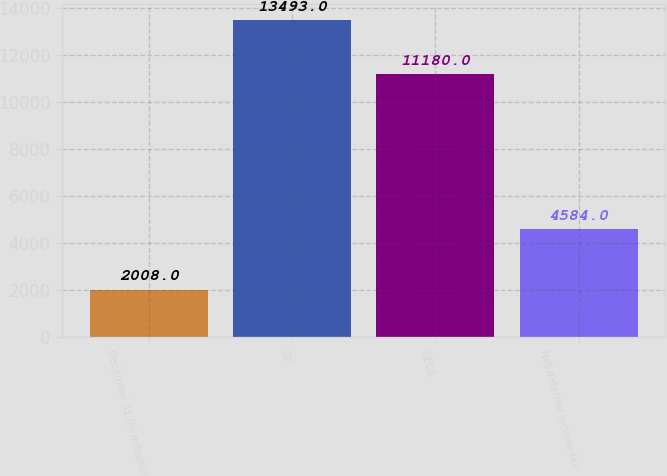Convert chart to OTSL. <chart><loc_0><loc_0><loc_500><loc_500><bar_chart><fcel>December 31 (In millions)<fcel>GE<fcel>GECS<fcel>Net deferred income tax<nl><fcel>2008<fcel>13493<fcel>11180<fcel>4584<nl></chart> 